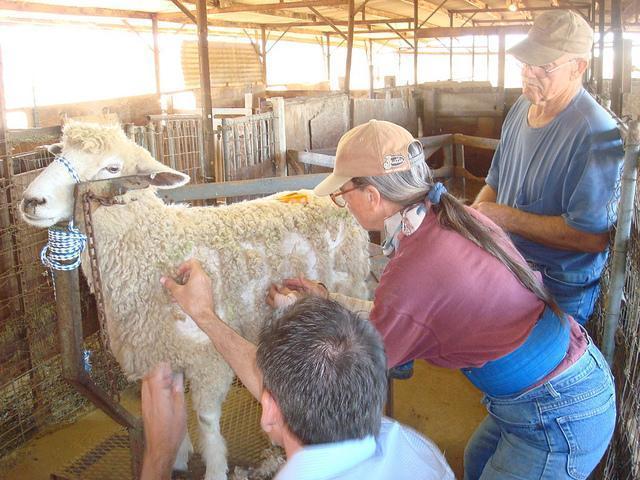How many people are wearing hats?
Give a very brief answer. 2. How many people can be seen?
Give a very brief answer. 3. 